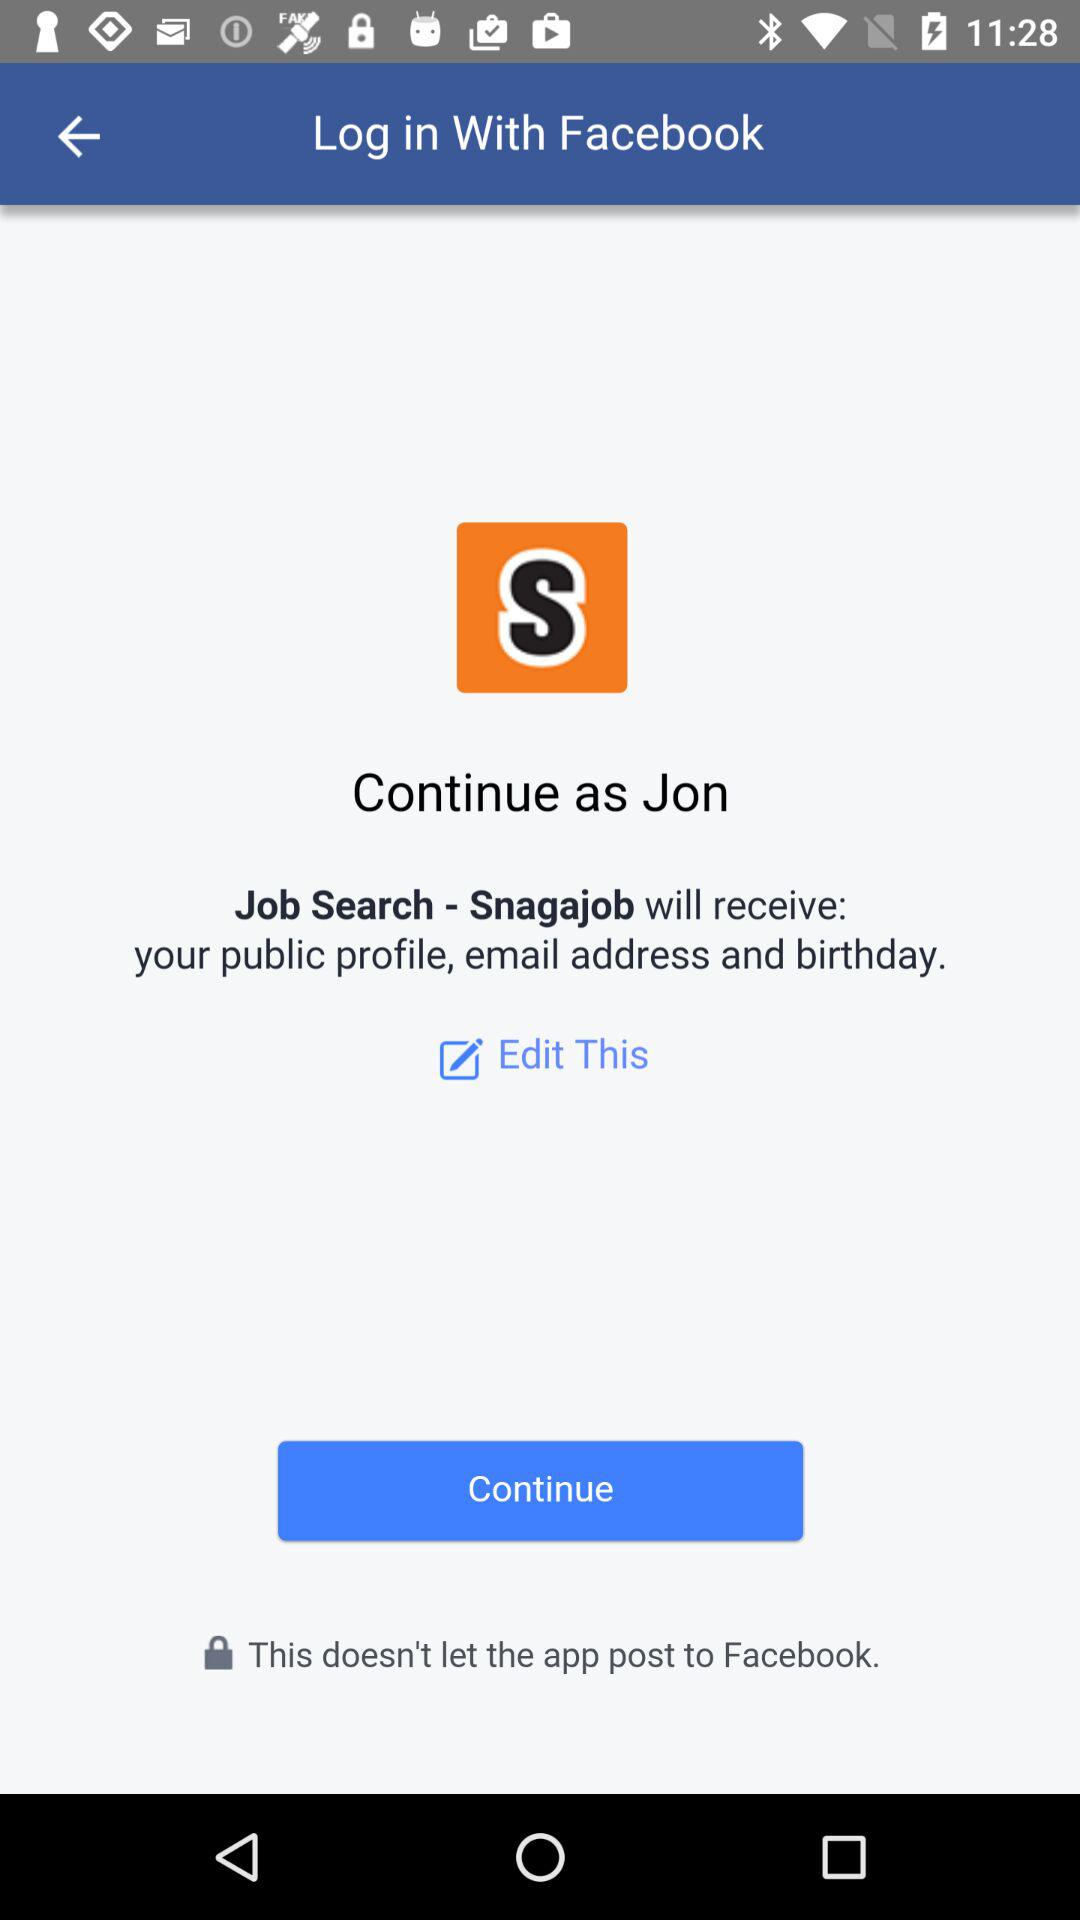What is the user name? The user name is Jon. 